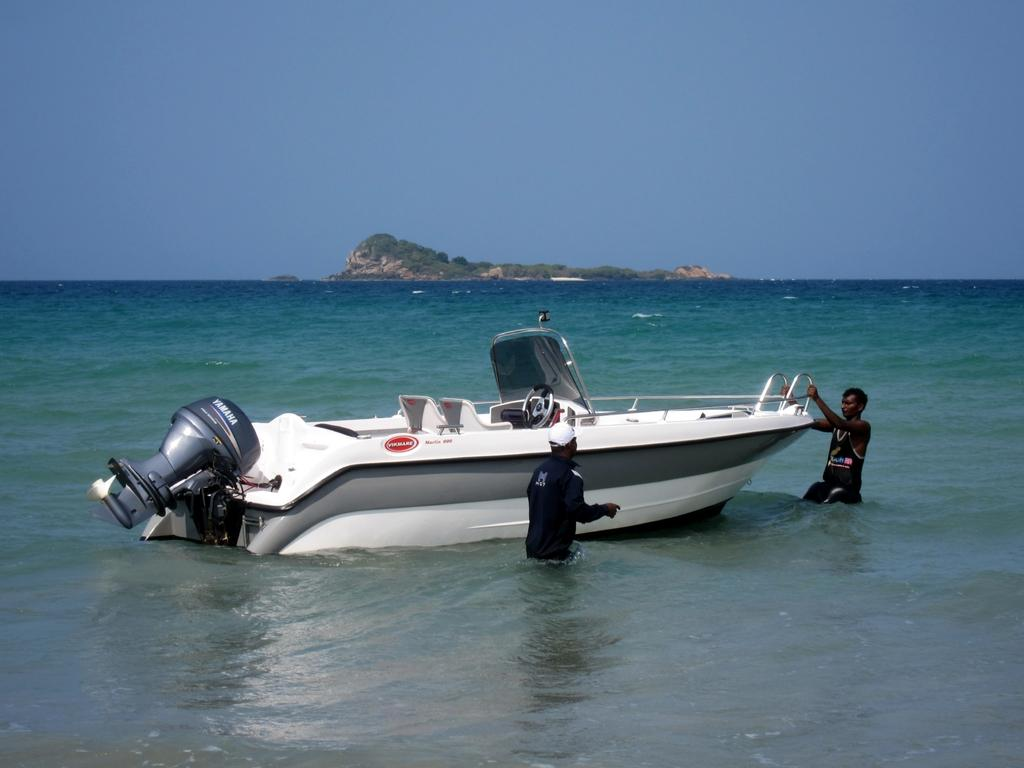How many people are in the image? There are two persons in the image. What is the main object in the image? There is a boat in the image. Where is the boat located? The boat is in a large water body. What other natural features can be seen in the image? There is a mountain visible in the image. What is the condition of the sky in the image? The sky appears cloudy in the image. What type of watch can be seen on the wrist of the person in the downtown area? There is no watch visible in the image, and the image does not depict a downtown area. 